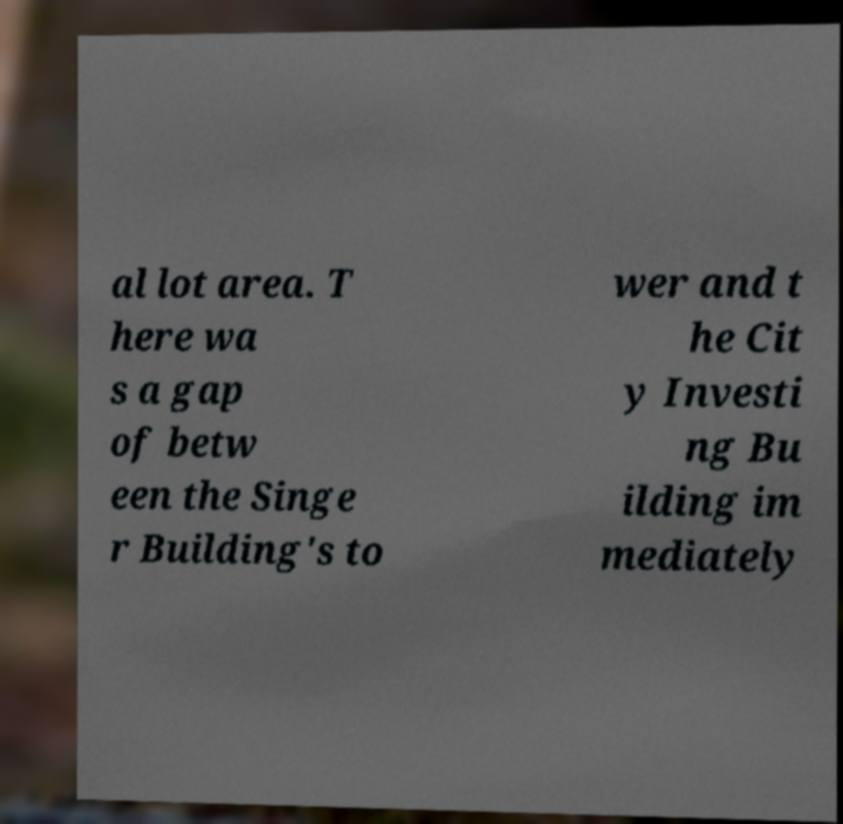Please read and relay the text visible in this image. What does it say? al lot area. T here wa s a gap of betw een the Singe r Building's to wer and t he Cit y Investi ng Bu ilding im mediately 